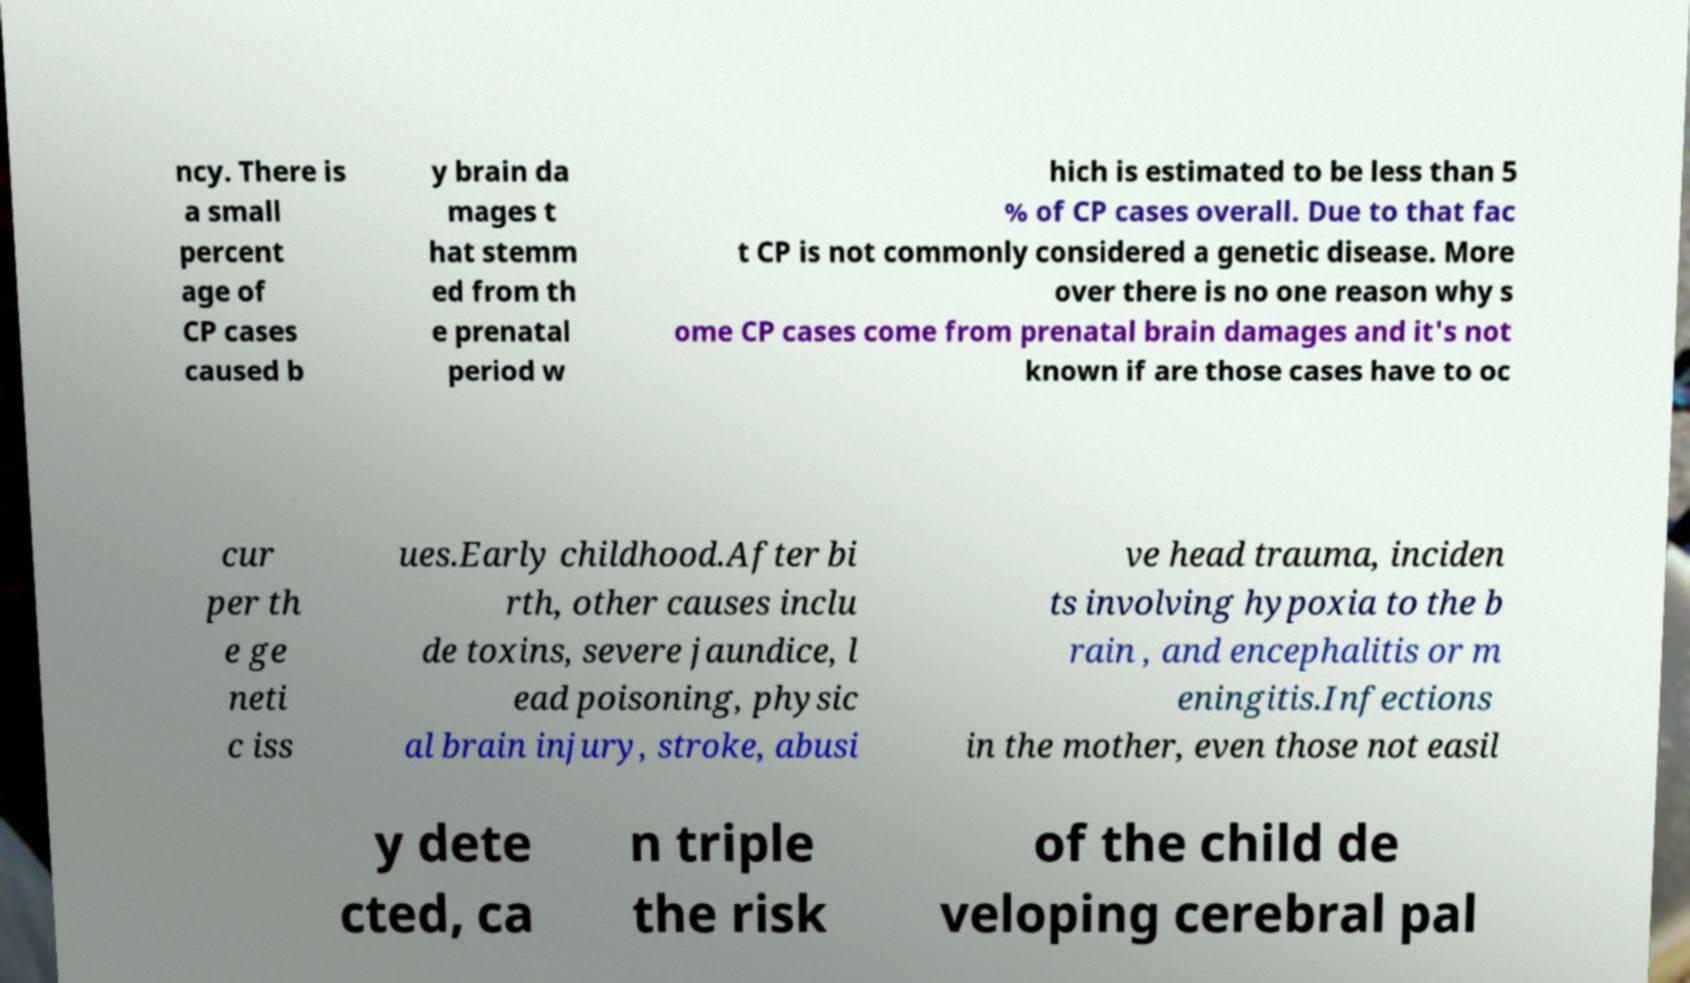What messages or text are displayed in this image? I need them in a readable, typed format. ncy. There is a small percent age of CP cases caused b y brain da mages t hat stemm ed from th e prenatal period w hich is estimated to be less than 5 % of CP cases overall. Due to that fac t CP is not commonly considered a genetic disease. More over there is no one reason why s ome CP cases come from prenatal brain damages and it's not known if are those cases have to oc cur per th e ge neti c iss ues.Early childhood.After bi rth, other causes inclu de toxins, severe jaundice, l ead poisoning, physic al brain injury, stroke, abusi ve head trauma, inciden ts involving hypoxia to the b rain , and encephalitis or m eningitis.Infections in the mother, even those not easil y dete cted, ca n triple the risk of the child de veloping cerebral pal 